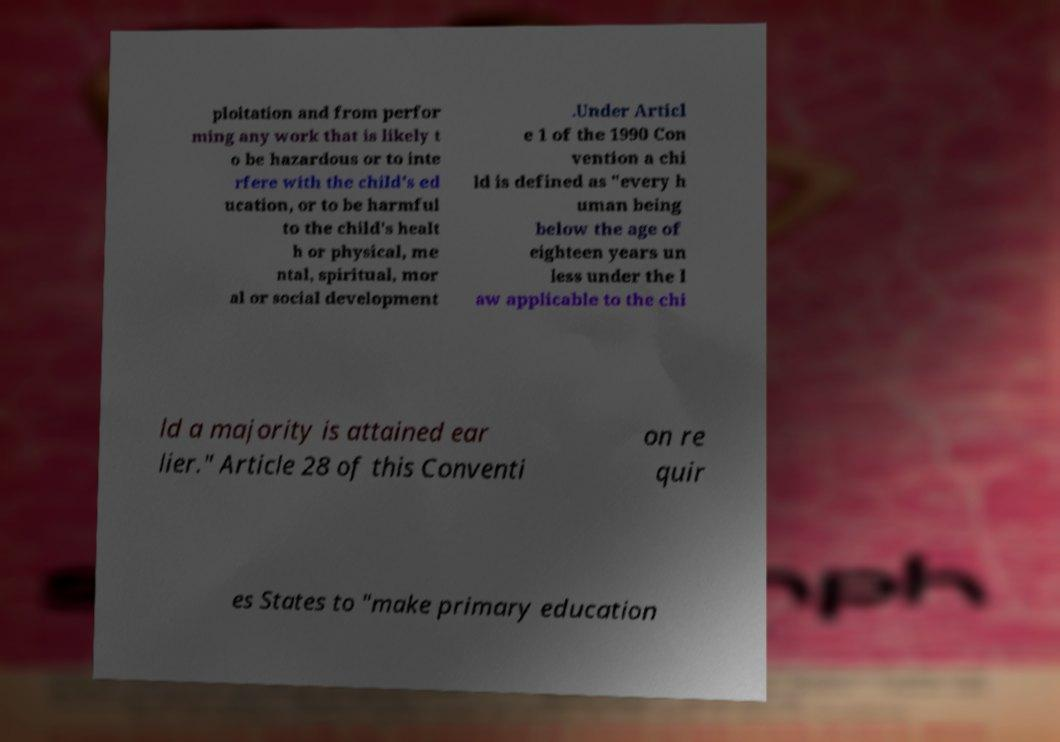Can you accurately transcribe the text from the provided image for me? ploitation and from perfor ming any work that is likely t o be hazardous or to inte rfere with the child's ed ucation, or to be harmful to the child's healt h or physical, me ntal, spiritual, mor al or social development .Under Articl e 1 of the 1990 Con vention a chi ld is defined as "every h uman being below the age of eighteen years un less under the l aw applicable to the chi ld a majority is attained ear lier." Article 28 of this Conventi on re quir es States to "make primary education 